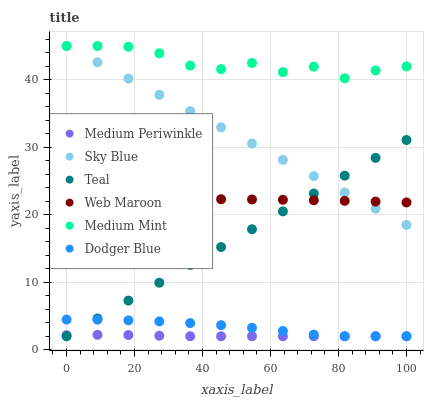Does Medium Periwinkle have the minimum area under the curve?
Answer yes or no. Yes. Does Medium Mint have the maximum area under the curve?
Answer yes or no. Yes. Does Web Maroon have the minimum area under the curve?
Answer yes or no. No. Does Web Maroon have the maximum area under the curve?
Answer yes or no. No. Is Teal the smoothest?
Answer yes or no. Yes. Is Medium Mint the roughest?
Answer yes or no. Yes. Is Medium Periwinkle the smoothest?
Answer yes or no. No. Is Medium Periwinkle the roughest?
Answer yes or no. No. Does Medium Periwinkle have the lowest value?
Answer yes or no. Yes. Does Web Maroon have the lowest value?
Answer yes or no. No. Does Sky Blue have the highest value?
Answer yes or no. Yes. Does Web Maroon have the highest value?
Answer yes or no. No. Is Dodger Blue less than Web Maroon?
Answer yes or no. Yes. Is Medium Mint greater than Dodger Blue?
Answer yes or no. Yes. Does Teal intersect Sky Blue?
Answer yes or no. Yes. Is Teal less than Sky Blue?
Answer yes or no. No. Is Teal greater than Sky Blue?
Answer yes or no. No. Does Dodger Blue intersect Web Maroon?
Answer yes or no. No. 